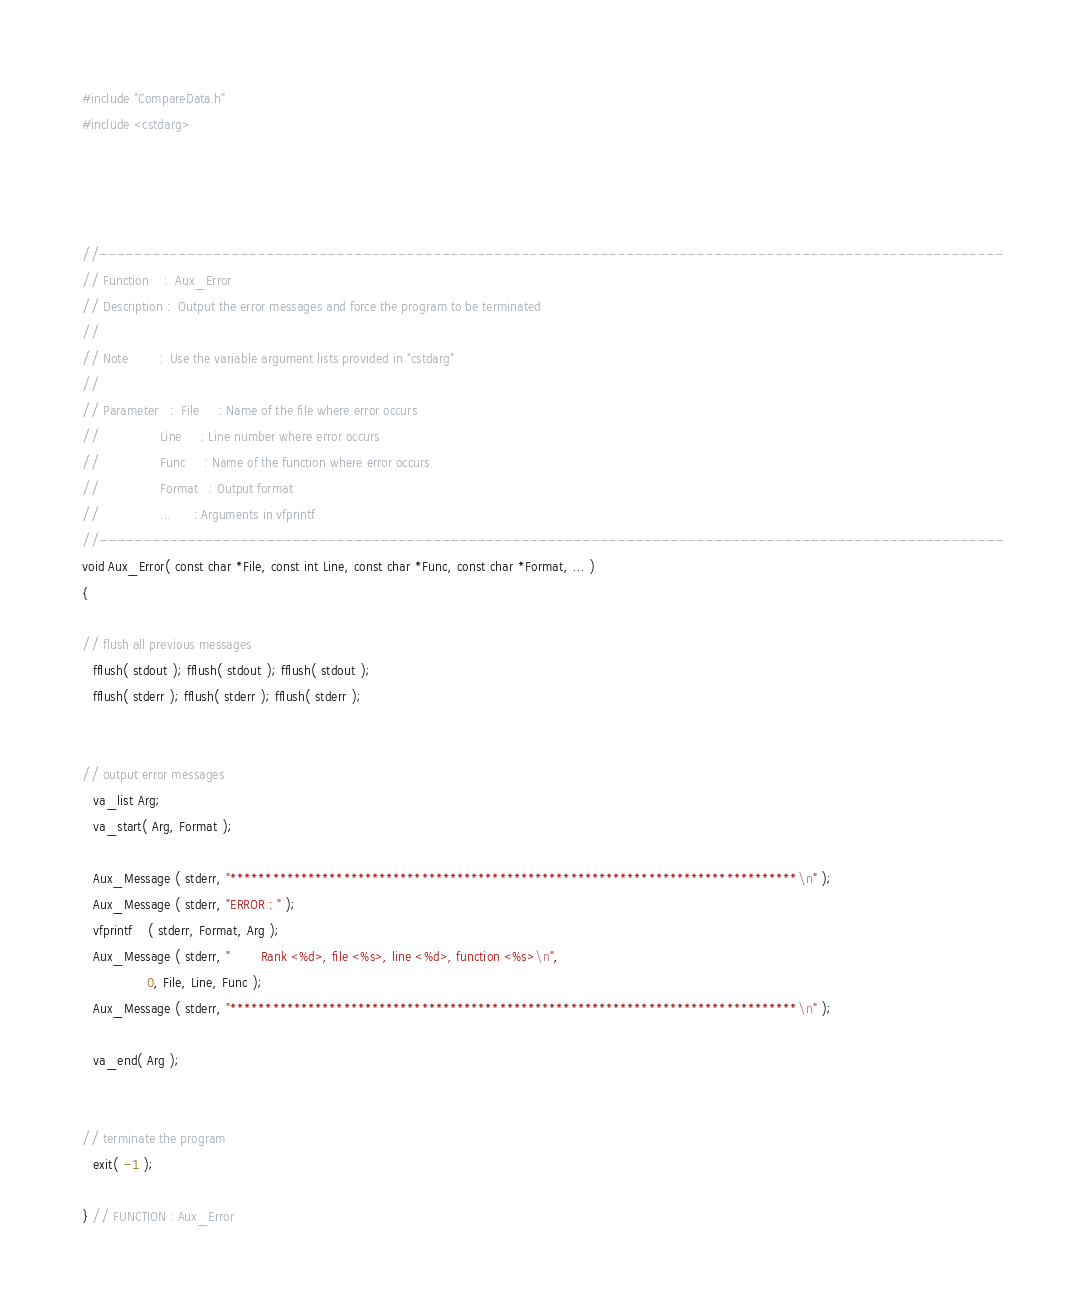Convert code to text. <code><loc_0><loc_0><loc_500><loc_500><_C++_>#include "CompareData.h"
#include <cstdarg>




//-------------------------------------------------------------------------------------------------------
// Function    :  Aux_Error
// Description :  Output the error messages and force the program to be terminated
//
// Note        :  Use the variable argument lists provided in "cstdarg"
//
// Parameter   :  File     : Name of the file where error occurs
//                Line     : Line number where error occurs
//                Func     : Name of the function where error occurs
//                Format   : Output format
//                ...      : Arguments in vfprintf
//-------------------------------------------------------------------------------------------------------
void Aux_Error( const char *File, const int Line, const char *Func, const char *Format, ... )
{

// flush all previous messages
   fflush( stdout ); fflush( stdout ); fflush( stdout );
   fflush( stderr ); fflush( stderr ); fflush( stderr );


// output error messages
   va_list Arg;
   va_start( Arg, Format );

   Aux_Message ( stderr, "********************************************************************************\n" );
   Aux_Message ( stderr, "ERROR : " );
   vfprintf    ( stderr, Format, Arg );
   Aux_Message ( stderr, "        Rank <%d>, file <%s>, line <%d>, function <%s>\n",
                 0, File, Line, Func );
   Aux_Message ( stderr, "********************************************************************************\n" );

   va_end( Arg );


// terminate the program
   exit( -1 );

} // FUNCTION : Aux_Error
</code> 